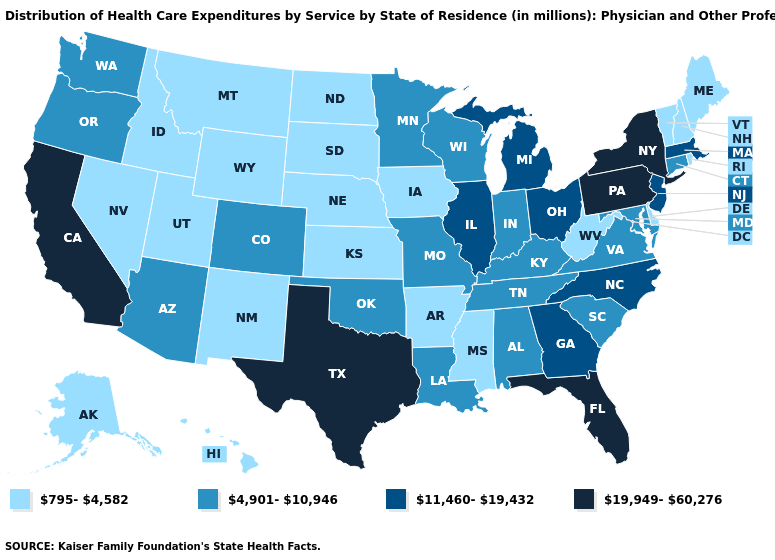Name the states that have a value in the range 19,949-60,276?
Answer briefly. California, Florida, New York, Pennsylvania, Texas. What is the value of Minnesota?
Quick response, please. 4,901-10,946. Name the states that have a value in the range 11,460-19,432?
Give a very brief answer. Georgia, Illinois, Massachusetts, Michigan, New Jersey, North Carolina, Ohio. What is the highest value in the West ?
Keep it brief. 19,949-60,276. What is the value of Wisconsin?
Keep it brief. 4,901-10,946. Among the states that border Massachusetts , does Vermont have the highest value?
Keep it brief. No. What is the value of New Hampshire?
Keep it brief. 795-4,582. Name the states that have a value in the range 4,901-10,946?
Concise answer only. Alabama, Arizona, Colorado, Connecticut, Indiana, Kentucky, Louisiana, Maryland, Minnesota, Missouri, Oklahoma, Oregon, South Carolina, Tennessee, Virginia, Washington, Wisconsin. Does California have the lowest value in the USA?
Concise answer only. No. What is the value of Maine?
Concise answer only. 795-4,582. How many symbols are there in the legend?
Keep it brief. 4. Does Vermont have the lowest value in the USA?
Write a very short answer. Yes. What is the value of West Virginia?
Give a very brief answer. 795-4,582. What is the highest value in states that border Tennessee?
Short answer required. 11,460-19,432. What is the highest value in the South ?
Write a very short answer. 19,949-60,276. 